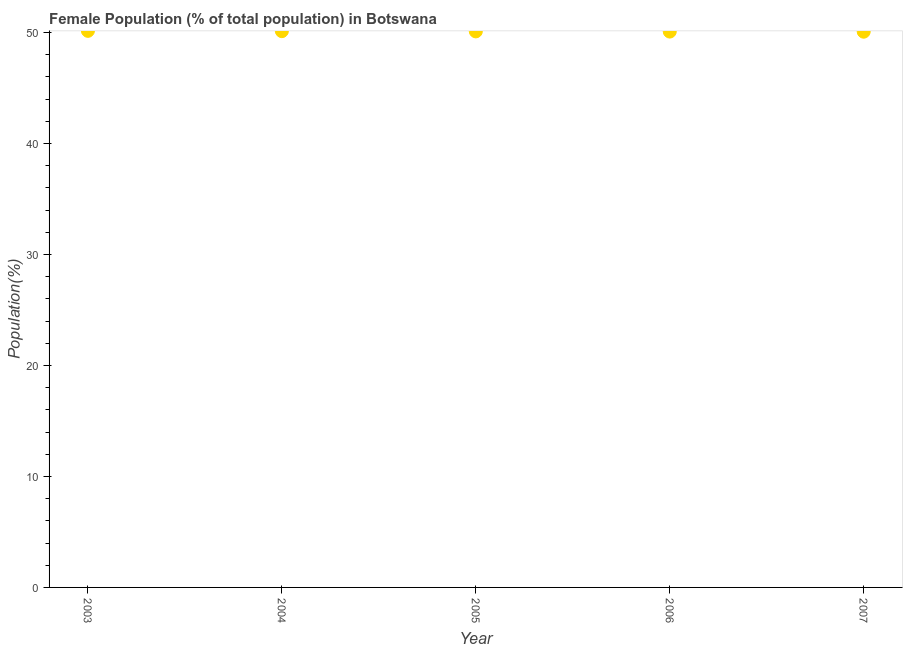What is the female population in 2005?
Your answer should be compact. 50.09. Across all years, what is the maximum female population?
Your answer should be compact. 50.14. Across all years, what is the minimum female population?
Provide a succinct answer. 50.07. In which year was the female population maximum?
Ensure brevity in your answer.  2003. In which year was the female population minimum?
Provide a short and direct response. 2007. What is the sum of the female population?
Your answer should be compact. 250.5. What is the difference between the female population in 2004 and 2007?
Offer a terse response. 0.05. What is the average female population per year?
Keep it short and to the point. 50.1. What is the median female population?
Make the answer very short. 50.09. Do a majority of the years between 2005 and 2006 (inclusive) have female population greater than 24 %?
Your answer should be compact. Yes. What is the ratio of the female population in 2006 to that in 2007?
Make the answer very short. 1. What is the difference between the highest and the second highest female population?
Make the answer very short. 0.03. Is the sum of the female population in 2004 and 2007 greater than the maximum female population across all years?
Ensure brevity in your answer.  Yes. What is the difference between the highest and the lowest female population?
Provide a short and direct response. 0.08. In how many years, is the female population greater than the average female population taken over all years?
Keep it short and to the point. 2. Are the values on the major ticks of Y-axis written in scientific E-notation?
Offer a terse response. No. Does the graph contain any zero values?
Offer a very short reply. No. What is the title of the graph?
Offer a very short reply. Female Population (% of total population) in Botswana. What is the label or title of the Y-axis?
Make the answer very short. Population(%). What is the Population(%) in 2003?
Offer a very short reply. 50.14. What is the Population(%) in 2004?
Provide a succinct answer. 50.12. What is the Population(%) in 2005?
Provide a short and direct response. 50.09. What is the Population(%) in 2006?
Your answer should be very brief. 50.08. What is the Population(%) in 2007?
Your answer should be compact. 50.07. What is the difference between the Population(%) in 2003 and 2004?
Your response must be concise. 0.03. What is the difference between the Population(%) in 2003 and 2005?
Keep it short and to the point. 0.05. What is the difference between the Population(%) in 2003 and 2006?
Your answer should be very brief. 0.06. What is the difference between the Population(%) in 2003 and 2007?
Your answer should be compact. 0.08. What is the difference between the Population(%) in 2004 and 2005?
Your answer should be compact. 0.02. What is the difference between the Population(%) in 2004 and 2006?
Keep it short and to the point. 0.04. What is the difference between the Population(%) in 2004 and 2007?
Keep it short and to the point. 0.05. What is the difference between the Population(%) in 2005 and 2006?
Provide a succinct answer. 0.02. What is the difference between the Population(%) in 2005 and 2007?
Your answer should be compact. 0.03. What is the difference between the Population(%) in 2006 and 2007?
Offer a very short reply. 0.01. What is the ratio of the Population(%) in 2003 to that in 2007?
Make the answer very short. 1. What is the ratio of the Population(%) in 2004 to that in 2005?
Ensure brevity in your answer.  1. What is the ratio of the Population(%) in 2004 to that in 2006?
Give a very brief answer. 1. What is the ratio of the Population(%) in 2005 to that in 2006?
Make the answer very short. 1. What is the ratio of the Population(%) in 2006 to that in 2007?
Keep it short and to the point. 1. 